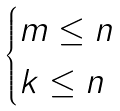Convert formula to latex. <formula><loc_0><loc_0><loc_500><loc_500>\begin{cases} m \leq n \\ k \leq n \end{cases}</formula> 